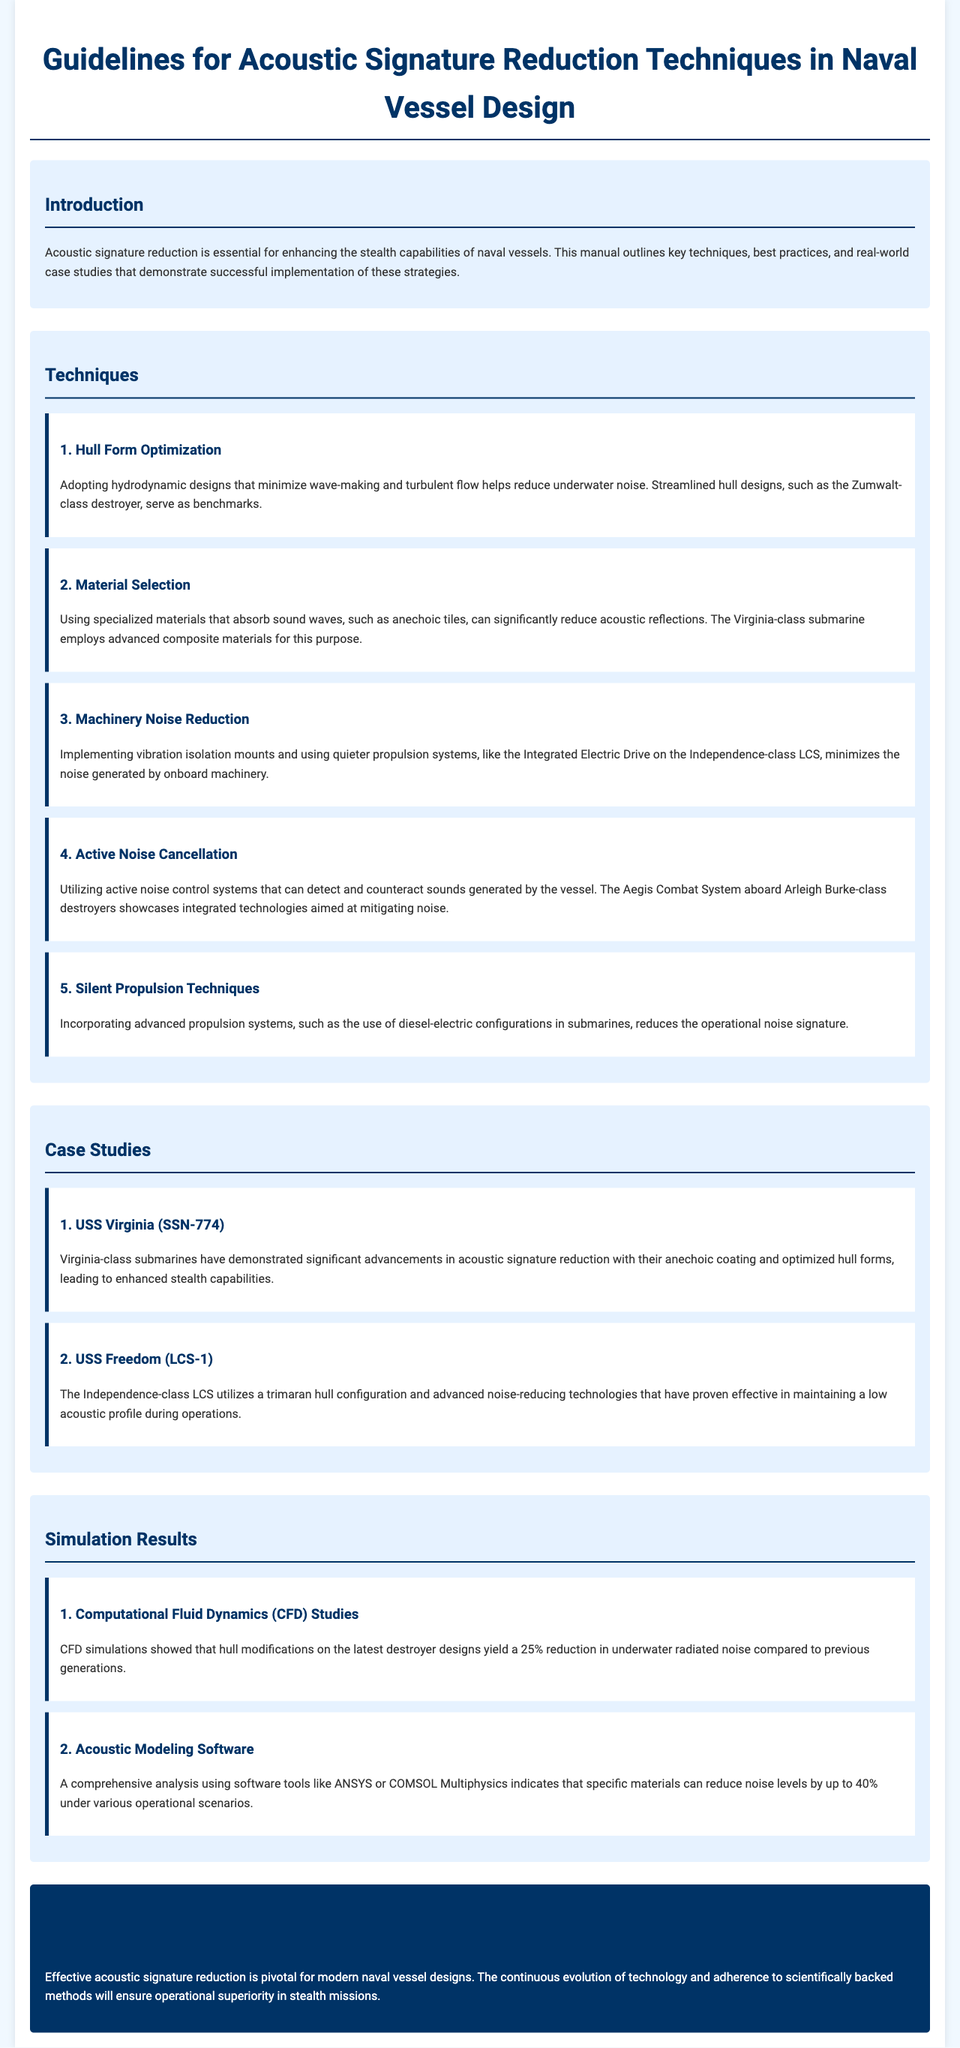What is the first technique for acoustic signature reduction? The first technique mentioned in the document is Hull Form Optimization, which focuses on hydrodynamic designs to minimize underwater noise.
Answer: Hull Form Optimization What is the Virginia-class submarine known for? The Virginia-class submarine is known for employing advanced composite materials for sound absorption, which reduces acoustic reflections.
Answer: Advanced composite materials What percentage reduction in underwater radiated noise was achieved in CFD simulations? According to the document, hull modifications on the latest destroyer designs yielded a 25% reduction in underwater radiated noise based on CFD simulations.
Answer: 25% Which naval vessel class utilizes active noise control systems? The document mentions that the Aegis Combat System aboard the Arleigh Burke-class destroyers showcases integrated technologies for noise mitigation.
Answer: Arleigh Burke-class What material is specifically highlighted for minimizing sound reflections? The manual discusses anechoic tiles as specialized materials that absorb sound waves to reduce reflections.
Answer: Anechoic tiles What propulsion technique is incorporated in submarines to reduce noise? The document states that advanced propulsion systems, like diesel-electric configurations, are used in submarines to lower operational noise signatures.
Answer: Diesel-electric configurations Which simulation tool was mentioned for acoustic modeling? The document refers to software tools like ANSYS or COMSOL Multiphysics for comprehensive acoustic modeling analysis.
Answer: ANSYS or COMSOL Multiphysics What is the overall goal of implementing acoustic signature reduction? The main goal is enhancing stealth capabilities of naval vessels, as stated in the introduction of the document.
Answer: Enhancing stealth capabilities What class of warship is cited for its reduced acoustic profile in case studies? The Independence-class LCS is cited for utilizing advanced technologies that maintain a low acoustic profile during operations.
Answer: Independence-class LCS 